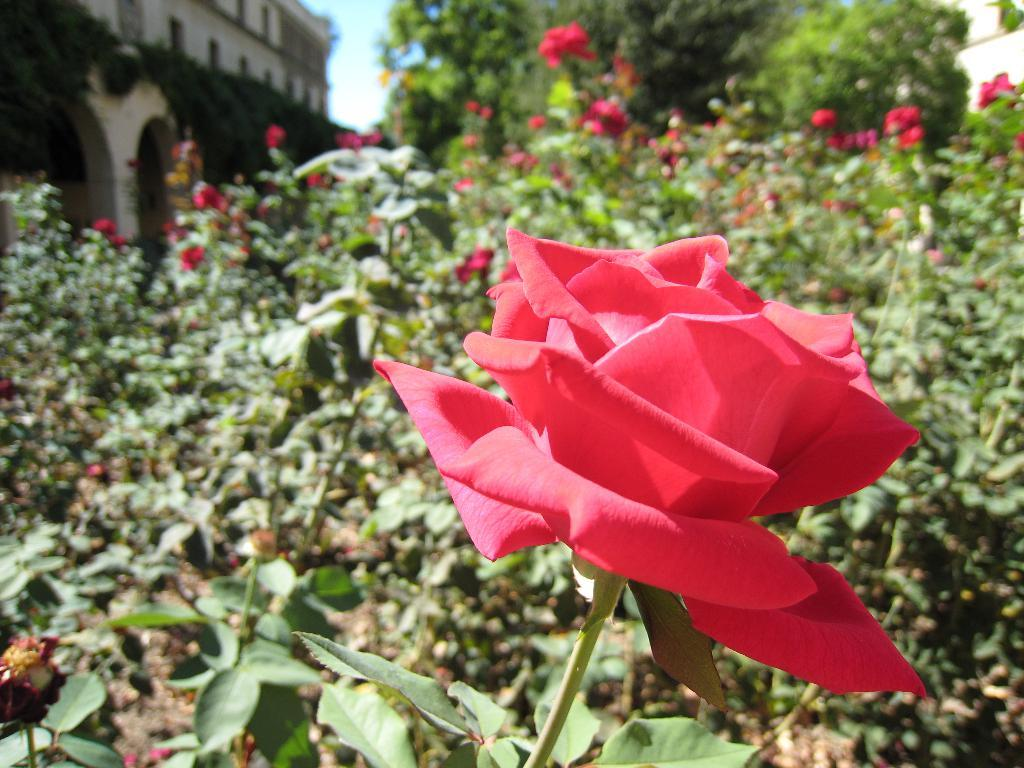What type of flowers can be seen in the image? There are rose flowers in the image. What other types of plants are present in the image? There are plants and trees in the image. What structure is visible in the image? There is a building in the image. What can be seen in the background of the image? The sky is visible in the background of the image. How does the whip affect the plants in the image? There is no whip present in the image, so it cannot affect the plants. What direction are the trees facing in the image? The trees do not have a specific direction they are facing in the image; they are stationary. 